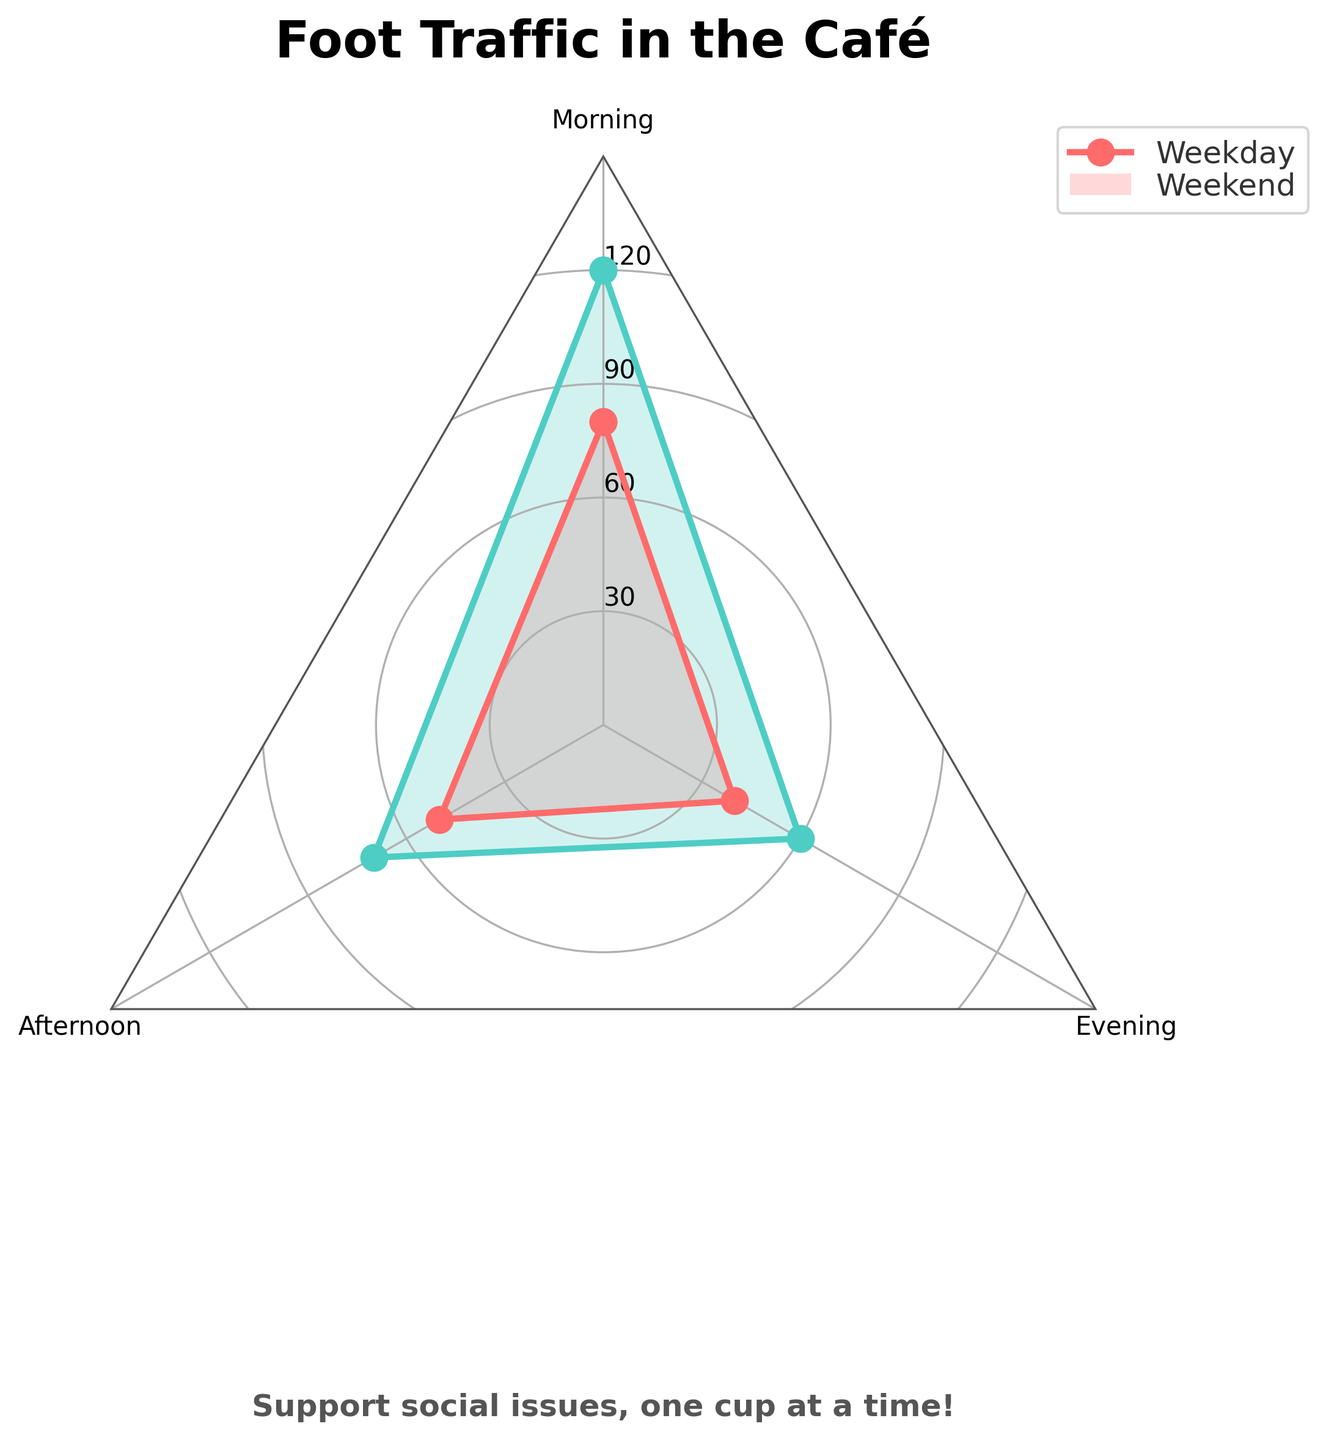What's the title of the chart? The title of the chart is seen at the top and reads "Foot Traffic in the Café".
Answer: Foot Traffic in the Café Which color represents Weekday foot traffic? By looking at the legend, we see that the color representing Weekday foot traffic is the red-like color labeled under "Weekday".
Answer: Red How many time segments are shown on the radar chart? The radar chart includes three segments, as indicated by the labels around the chart: Morning, Afternoon, and Evening.
Answer: 3 During which time of day is Weekend foot traffic the highest? Observing the peaks on the radar chart, the Weekend foot traffic is highest in the Morning.
Answer: Morning What is the approximate foot traffic value for Weekday afternoons? The radar chart for Weekdays shows a point at around 50 during the Afternoon segment.
Answer: 50 How much more foot traffic is there on Weekend mornings compared to Weekday mornings? The radar chart shows 120 for Weekend mornings and 80 for Weekday mornings. The difference is 120 - 80 = 40.
Answer: 40 What is the average foot traffic for Weekdays in all time segments? The foot traffic values for Weekdays are 80 (Morning), 50 (Afternoon), and 40 (Evening). The average is (80 + 50 + 40) / 3 = 170 / 3 ≈ 56.67.
Answer: 56.67 Compare the foot traffic in the Evening for both Weekdays and Weekends. Which has more? The radar chart indicates that Evening foot traffic on Weekends (60) is higher than on Weekdays (40).
Answer: Weekend Is there a time segment where foot traffic is equal for both Weekdays and Weekends? By examining the radar chart, we notice that foot traffic is never equal in any time segment for both Weekdays and Weekends.
Answer: No In which time of day does the café experience the lowest Weekday foot traffic? The lowest point on the radar chart for Weekday foot traffic is in the Evening.
Answer: Evening 